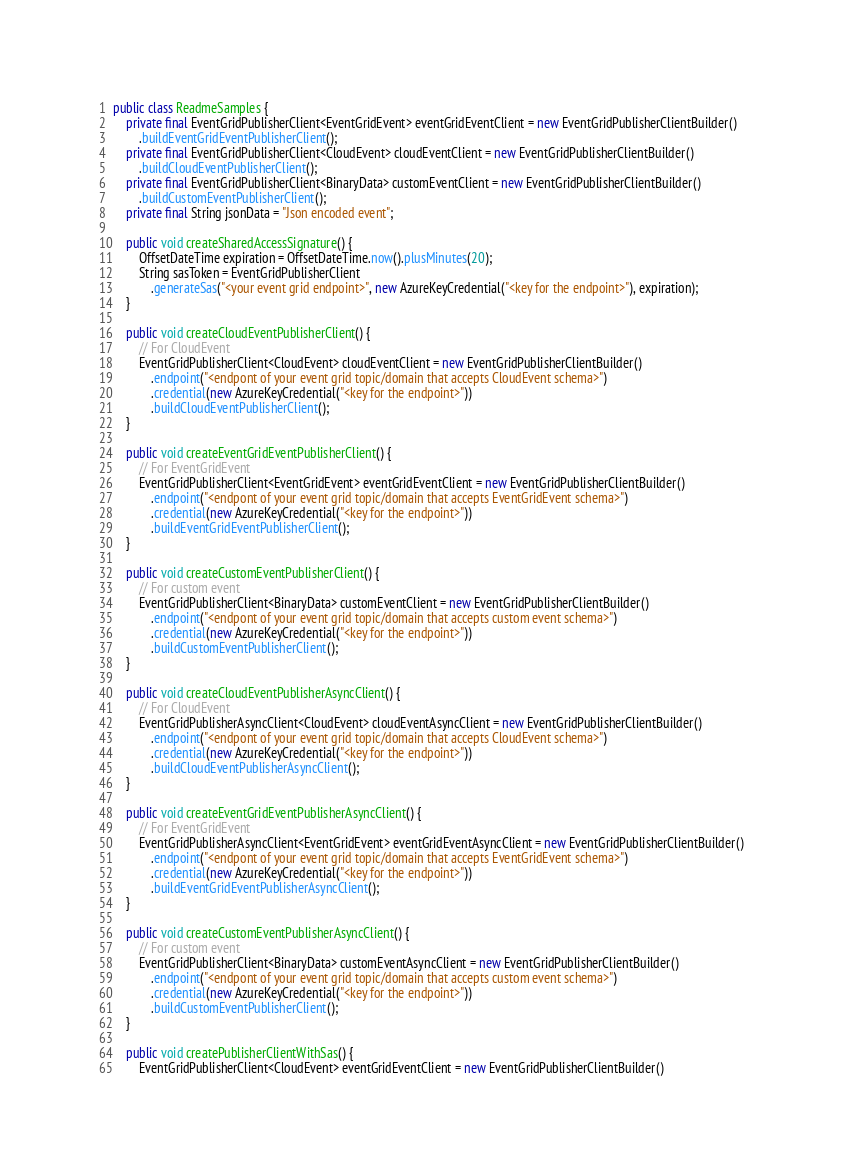Convert code to text. <code><loc_0><loc_0><loc_500><loc_500><_Java_>
public class ReadmeSamples {
    private final EventGridPublisherClient<EventGridEvent> eventGridEventClient = new EventGridPublisherClientBuilder()
        .buildEventGridEventPublisherClient();
    private final EventGridPublisherClient<CloudEvent> cloudEventClient = new EventGridPublisherClientBuilder()
        .buildCloudEventPublisherClient();
    private final EventGridPublisherClient<BinaryData> customEventClient = new EventGridPublisherClientBuilder()
        .buildCustomEventPublisherClient();
    private final String jsonData = "Json encoded event";

    public void createSharedAccessSignature() {
        OffsetDateTime expiration = OffsetDateTime.now().plusMinutes(20);
        String sasToken = EventGridPublisherClient
            .generateSas("<your event grid endpoint>", new AzureKeyCredential("<key for the endpoint>"), expiration);
    }

    public void createCloudEventPublisherClient() {
        // For CloudEvent
        EventGridPublisherClient<CloudEvent> cloudEventClient = new EventGridPublisherClientBuilder()
            .endpoint("<endpont of your event grid topic/domain that accepts CloudEvent schema>")
            .credential(new AzureKeyCredential("<key for the endpoint>"))
            .buildCloudEventPublisherClient();
    }

    public void createEventGridEventPublisherClient() {
        // For EventGridEvent
        EventGridPublisherClient<EventGridEvent> eventGridEventClient = new EventGridPublisherClientBuilder()
            .endpoint("<endpont of your event grid topic/domain that accepts EventGridEvent schema>")
            .credential(new AzureKeyCredential("<key for the endpoint>"))
            .buildEventGridEventPublisherClient();
    }

    public void createCustomEventPublisherClient() {
        // For custom event
        EventGridPublisherClient<BinaryData> customEventClient = new EventGridPublisherClientBuilder()
            .endpoint("<endpont of your event grid topic/domain that accepts custom event schema>")
            .credential(new AzureKeyCredential("<key for the endpoint>"))
            .buildCustomEventPublisherClient();
    }

    public void createCloudEventPublisherAsyncClient() {
        // For CloudEvent
        EventGridPublisherAsyncClient<CloudEvent> cloudEventAsyncClient = new EventGridPublisherClientBuilder()
            .endpoint("<endpont of your event grid topic/domain that accepts CloudEvent schema>")
            .credential(new AzureKeyCredential("<key for the endpoint>"))
            .buildCloudEventPublisherAsyncClient();
    }

    public void createEventGridEventPublisherAsyncClient() {
        // For EventGridEvent
        EventGridPublisherAsyncClient<EventGridEvent> eventGridEventAsyncClient = new EventGridPublisherClientBuilder()
            .endpoint("<endpont of your event grid topic/domain that accepts EventGridEvent schema>")
            .credential(new AzureKeyCredential("<key for the endpoint>"))
            .buildEventGridEventPublisherAsyncClient();
    }

    public void createCustomEventPublisherAsyncClient() {
        // For custom event
        EventGridPublisherClient<BinaryData> customEventAsyncClient = new EventGridPublisherClientBuilder()
            .endpoint("<endpont of your event grid topic/domain that accepts custom event schema>")
            .credential(new AzureKeyCredential("<key for the endpoint>"))
            .buildCustomEventPublisherClient();
    }

    public void createPublisherClientWithSas() {
        EventGridPublisherClient<CloudEvent> eventGridEventClient = new EventGridPublisherClientBuilder()</code> 